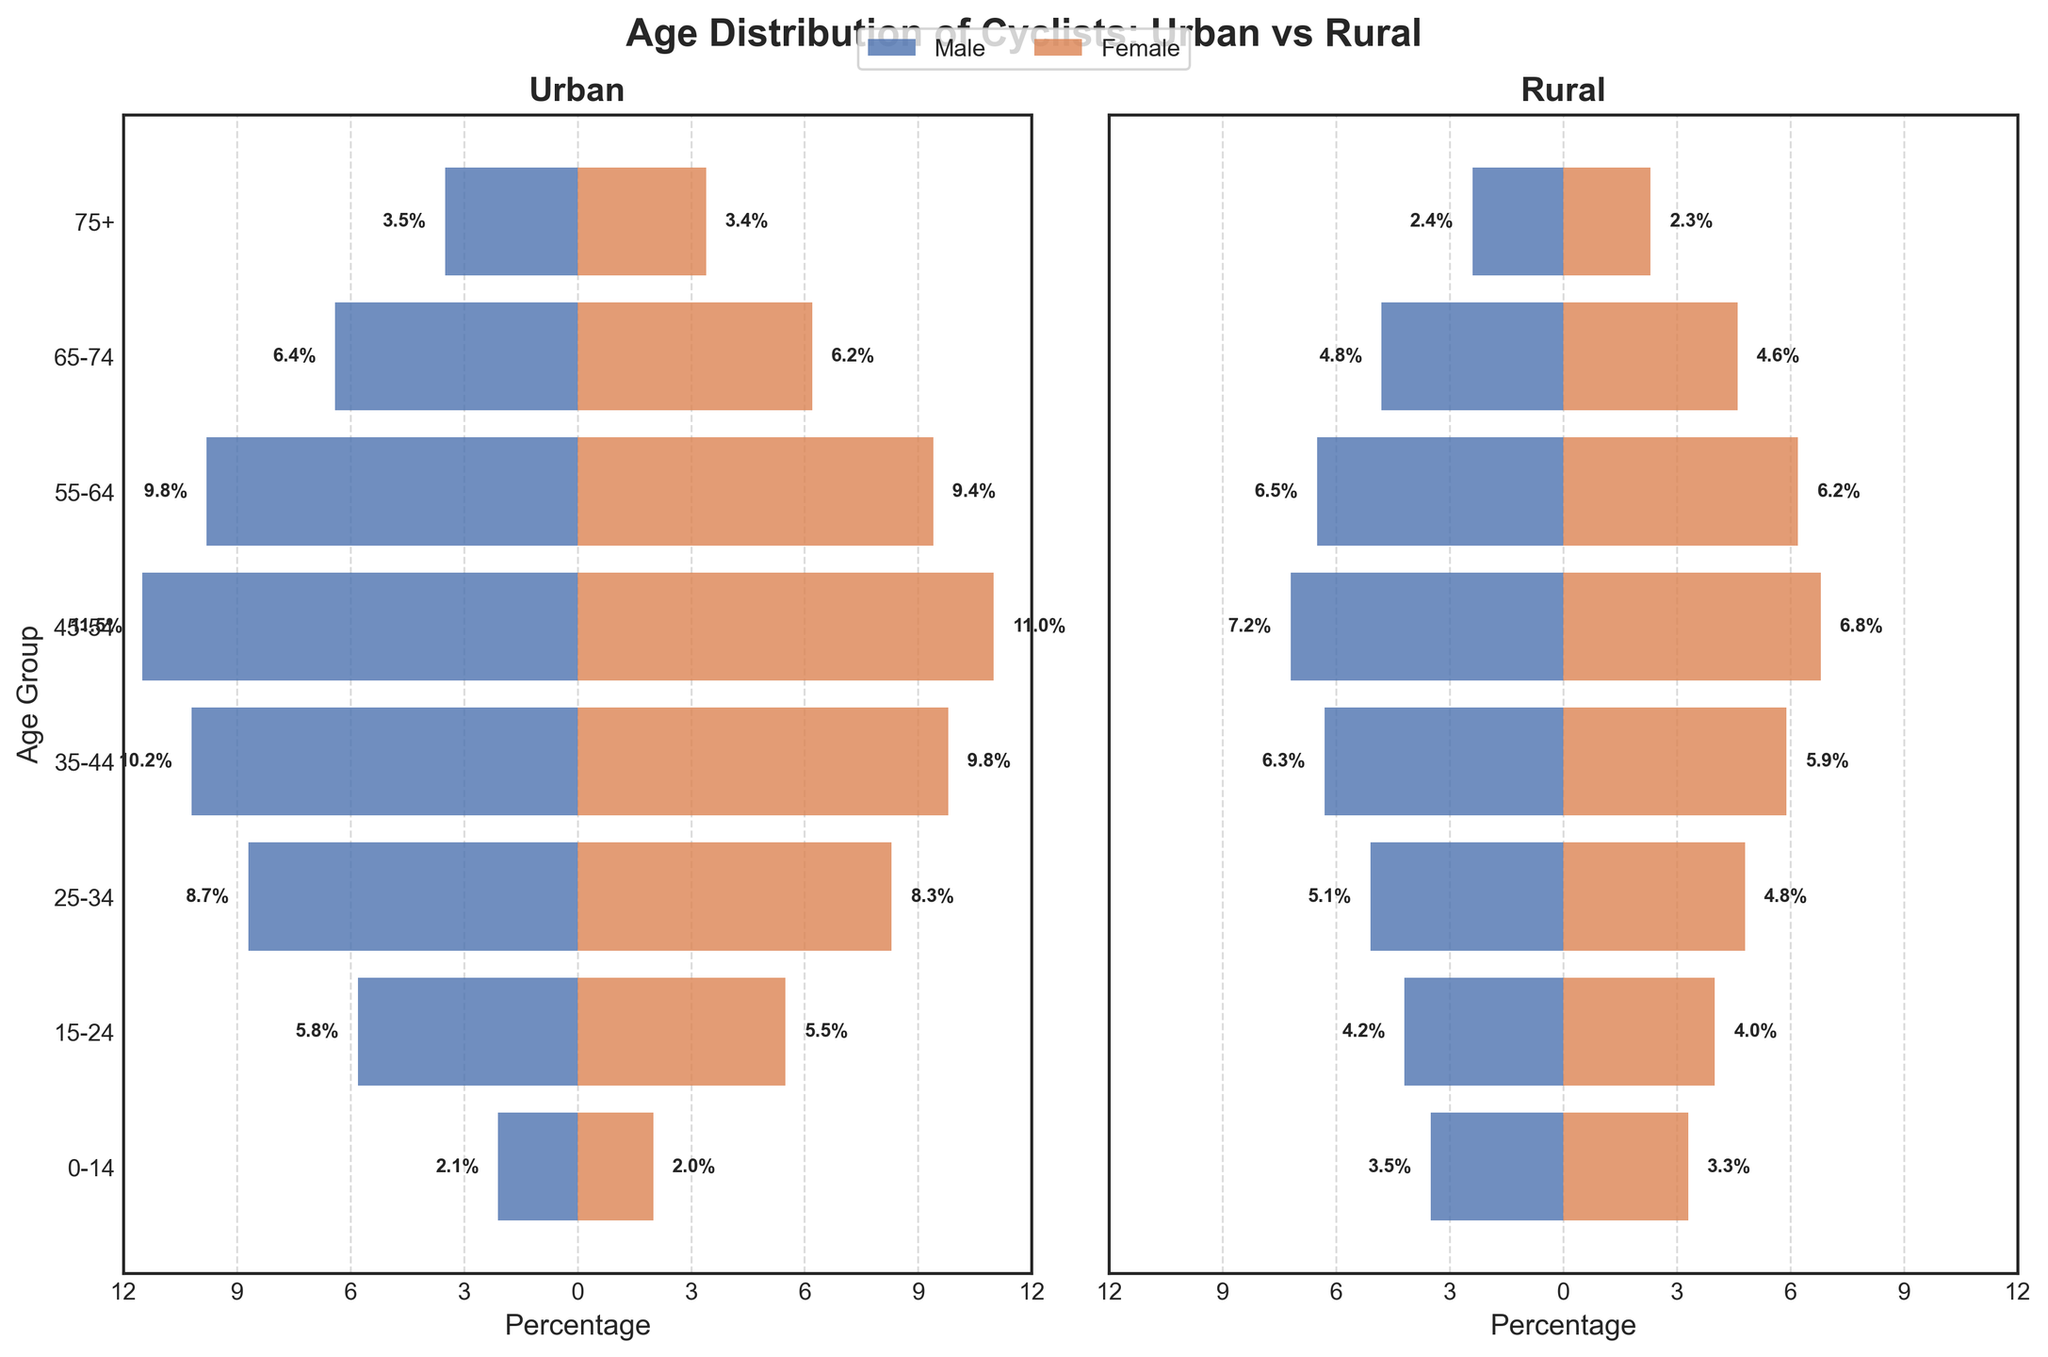What is the title of the figure? The title is located at the top of the figure. It reads "Age Distribution of Cyclists: Urban vs Rural".
Answer: Age Distribution of Cyclists: Urban vs Rural Which age group has the highest percentage of urban female cyclists? By looking at the bars representing urban female cyclists on the left plot, we observe that the age group "35-44" has the highest percentage with 9.8%.
Answer: 35-44 What's the difference in percentage between urban males and females in the 45-54 age group? The percentage of urban male cyclists in the 45-54 age group is 11.5% and for females, it's 11.0%. The difference is calculated as 11.5% - 11.0% = 0.5%.
Answer: 0.5% Which gender has a higher percentage of cyclists aged 25-34 in rural areas? Focus on the bars for the age group "25-34" on the right plot. Compare the length of the bars for males and females. The percentage for rural male cyclists is 5.1%, and for females, it's 4.8%. Males have a higher percentage.
Answer: Male What are the total percentages of urban cyclists aged 35-44 when combining both genders? The percentage of urban male cyclists aged 35-44 is 10.2% and for females, it's 9.8%. The total is 10.2% + 9.8% = 20.0%.
Answer: 20.0% How does the percentage of rural male cyclists aged 0-14 compare to urban male cyclists of the same age? The percentage of rural male cyclists aged 0-14 is 3.5%, whereas for urban males it is 2.1%. Rural males have a higher percentage by 1.4% (3.5% - 2.1%).
Answer: Rural males have a higher percentage by 1.4% In the 65-74 age group, what is the ratio of urban female cyclists to rural female cyclists? The percentage of urban female cyclists in the 65-74 age group is 6.2%, and for rural females, it's 4.6%. The ratio is calculated as 6.2% / 4.6% ≈ 1.35.
Answer: 1.35 Which age group shows the smallest difference between urban male and female cyclist percentages? By comparing the differences across all age groups, the age group "0-14" has the smallest difference: 2.1% for males and 2.0% for females, giving a difference of 0.1%.
Answer: 0-14 Is there any age group where the percentage of female cyclists is higher than male cyclists in both urban and rural areas? For each age group, compare the percentages for females and males in both urban and rural areas. The "0-14" age group has 2.0% female (urban) vs. 2.1% male (urban) and 3.3% female (rural) vs. 3.5% male (rural). No such age group is found.
Answer: No What is the combined percentage of rural male and female cyclists aged 75+? The percentage of rural male cyclists aged 75+ is 2.4% and for females, it's 2.3%. The combined percentage is 2.4% + 2.3% = 4.7%.
Answer: 4.7% 